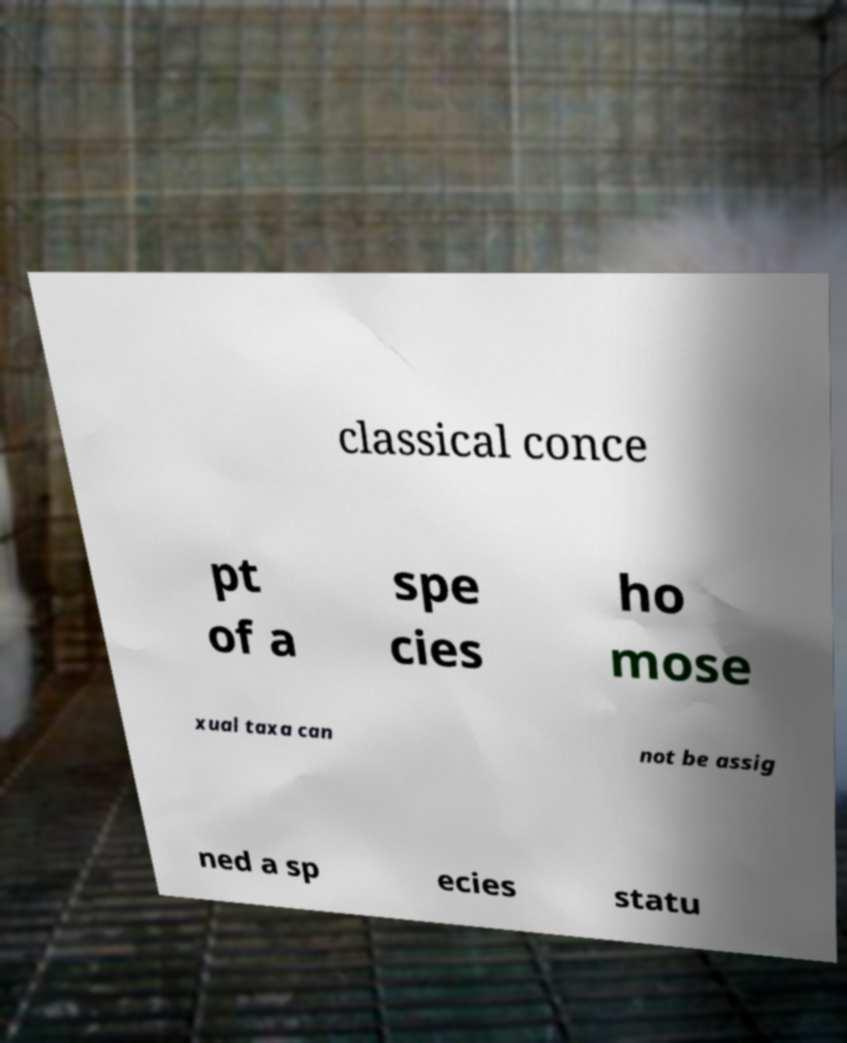I need the written content from this picture converted into text. Can you do that? classical conce pt of a spe cies ho mose xual taxa can not be assig ned a sp ecies statu 